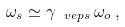Convert formula to latex. <formula><loc_0><loc_0><loc_500><loc_500>\omega _ { s } \simeq \gamma _ { \ v e p s } \, \omega _ { o } \, ,</formula> 